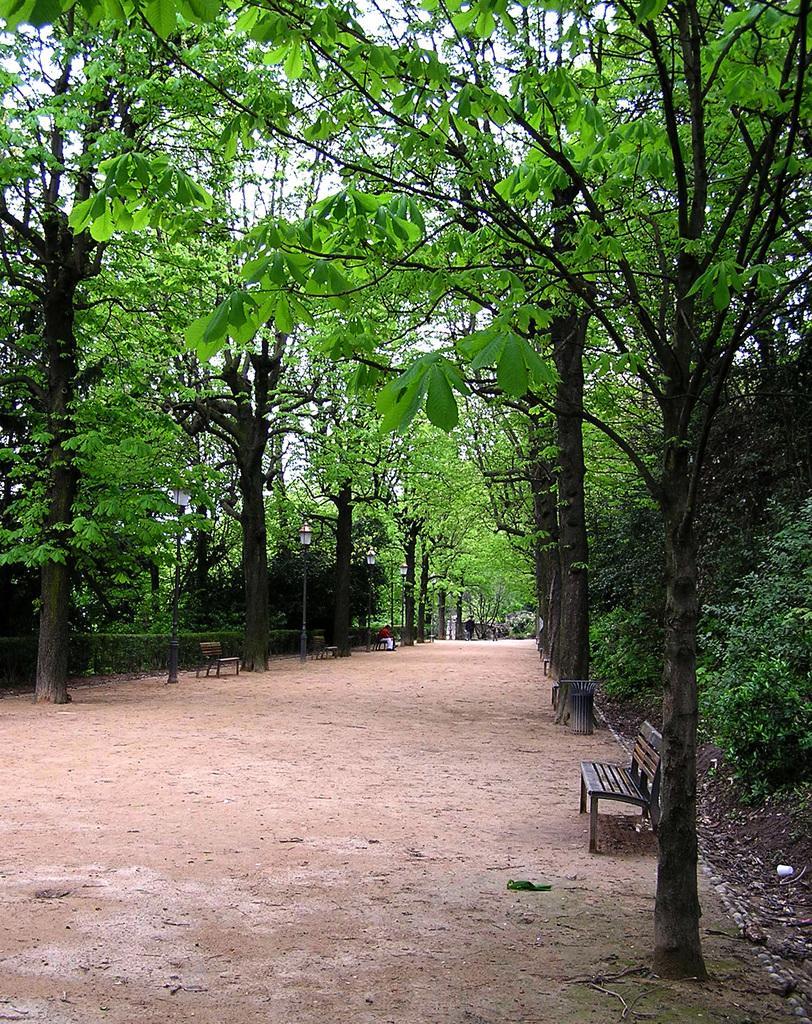How would you summarize this image in a sentence or two? This image is taken outdoors. At the bottom of the image there is a ground. In the middle of the image there are many trees and plants on the ground and there are a few empty benches. 